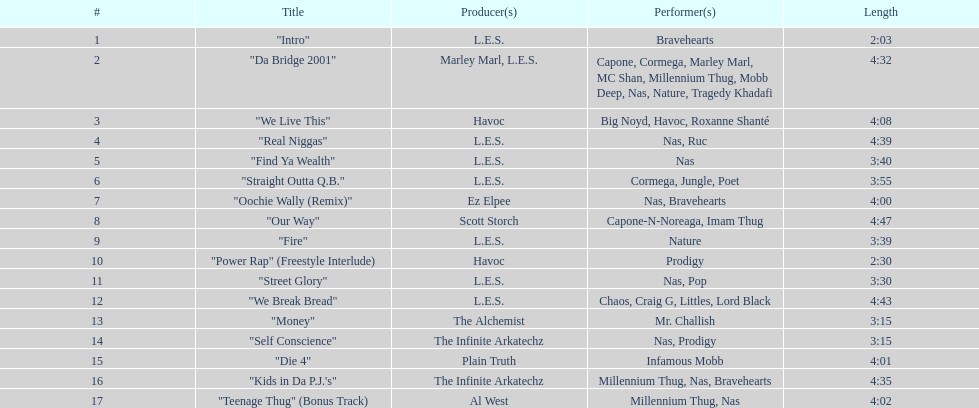What is the duration of the lengthiest track on the record? 4:47. 